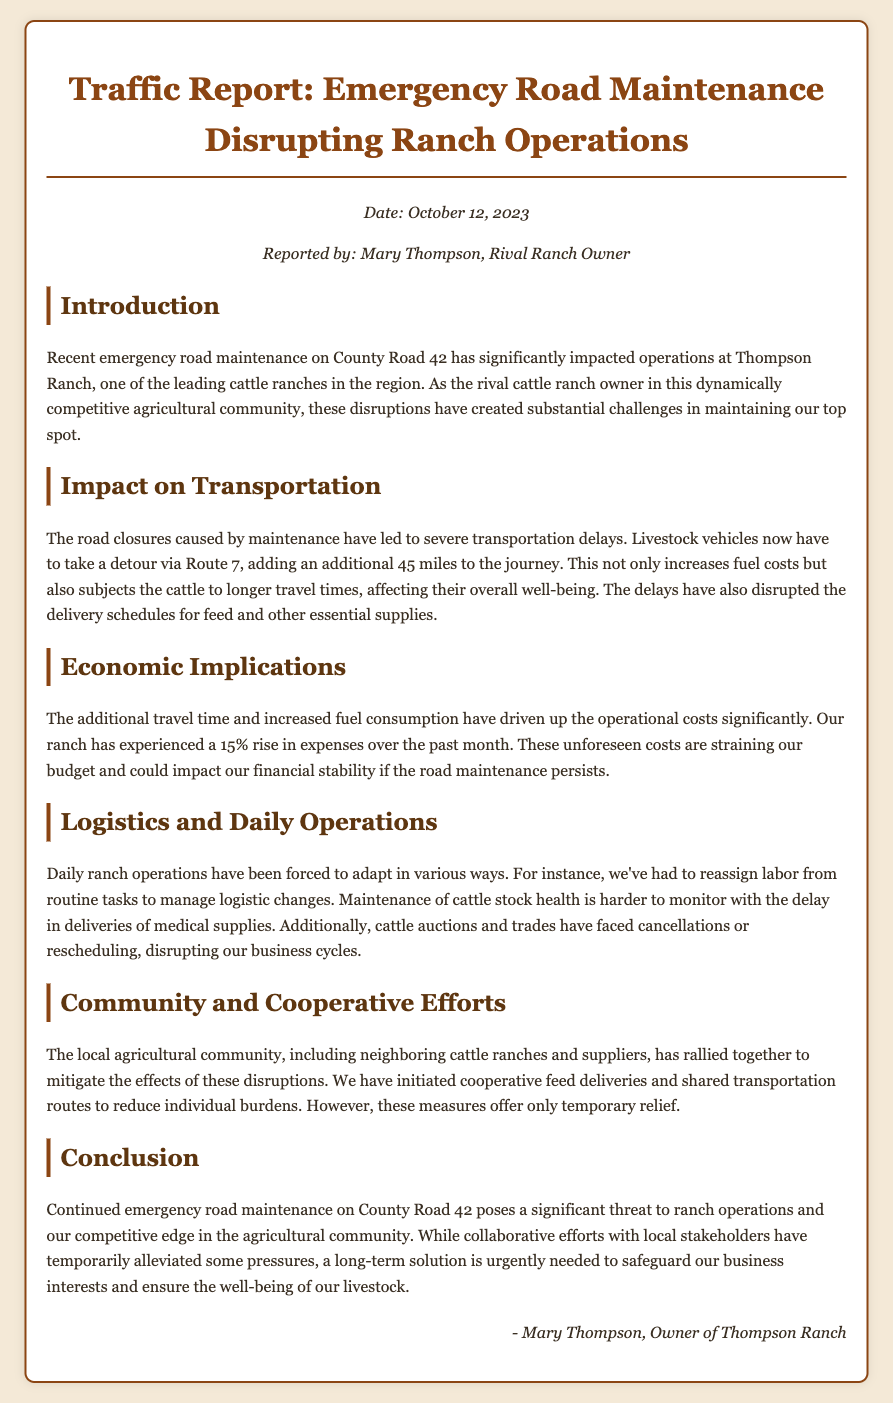What is the date of the report? The report provides the date at the top, which is October 12, 2023.
Answer: October 12, 2023 Who reported the document? The document indicates that it was reported by Mary Thompson, who is identified as a rival ranch owner.
Answer: Mary Thompson What is the additional distance that transportation vehicles must take? The document states that the detour adds an additional 45 miles to the journey.
Answer: 45 miles By what percentage have the operational costs increased? The document notes that there has been a 15% rise in expenses over the past month.
Answer: 15% What road is undergoing emergency maintenance? The emergency maintenance is specified to be on County Road 42.
Answer: County Road 42 What has been disrupted due to the road closures? The document mentions that delivery schedules for feed and essential supplies have been disrupted.
Answer: Delivery schedules What kind of cooperative efforts have been initiated? The report highlights that there have been cooperative feed deliveries to help mitigate disruption effects.
Answer: Cooperative feed deliveries What is the major threat to ranch operations mentioned in the conclusion? The conclusion emphasizes that continued emergency road maintenance poses a significant threat.
Answer: Continued emergency road maintenance 